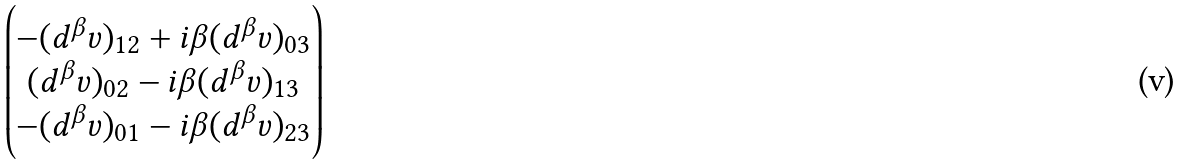Convert formula to latex. <formula><loc_0><loc_0><loc_500><loc_500>\begin{pmatrix} - ( d ^ { \beta } v ) _ { 1 2 } + i \beta ( d ^ { \beta } v ) _ { 0 3 } \\ ( d ^ { \beta } v ) _ { 0 2 } - i \beta ( d ^ { \beta } v ) _ { 1 3 } \\ - ( d ^ { \beta } v ) _ { 0 1 } - i \beta ( d ^ { \beta } v ) _ { 2 3 } \end{pmatrix}</formula> 